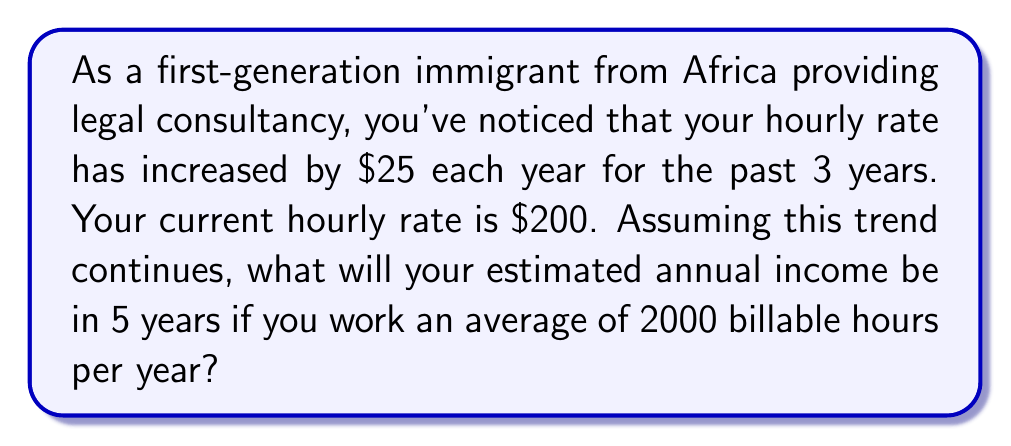Give your solution to this math problem. Let's approach this problem step-by-step:

1) First, we need to calculate the hourly rate in 5 years:
   - Current rate: $200/hour
   - Annual increase: $25/hour
   - Number of years: 5

   Future hourly rate = Current rate + (Annual increase × Number of years)
   $$200 + (25 × 5) = 200 + 125 = 325$$

2) Now we know that in 5 years, the hourly rate will be $325.

3) To calculate the annual income, we multiply this hourly rate by the number of billable hours per year:
   $$\text{Annual Income} = \text{Hourly Rate} × \text{Billable Hours}$$
   $$325 × 2000 = 650,000$$

Therefore, the estimated annual income in 5 years will be $650,000.
Answer: $650,000 